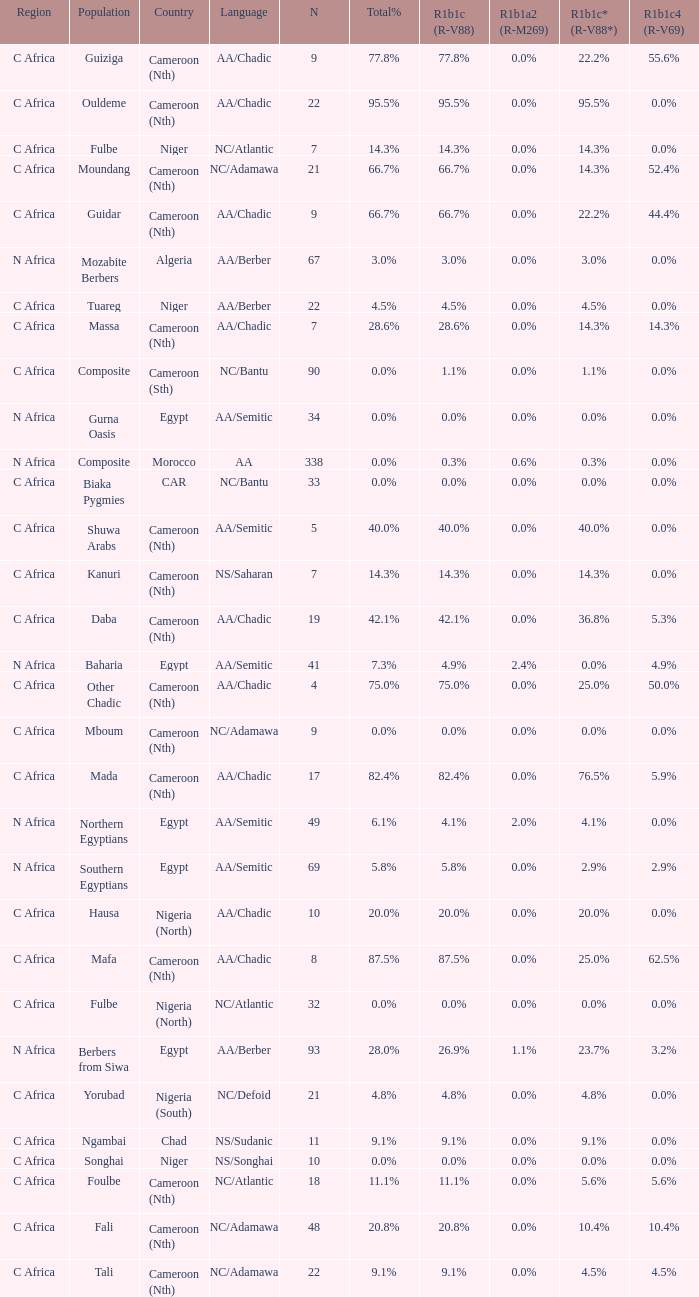What percentage is listed in column r1b1a2 (r-m269) for the 77.8% r1b1c (r-v88)? 0.0%. 